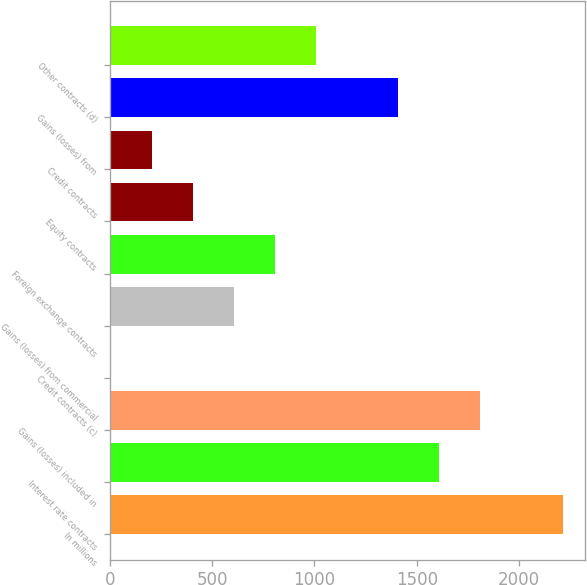Convert chart to OTSL. <chart><loc_0><loc_0><loc_500><loc_500><bar_chart><fcel>In millions<fcel>Interest rate contracts<fcel>Gains (losses) included in<fcel>Credit contracts (c)<fcel>Gains (losses) from commercial<fcel>Foreign exchange contracts<fcel>Equity contracts<fcel>Credit contracts<fcel>Gains (losses) from<fcel>Other contracts (d)<nl><fcel>2212.9<fcel>1610.2<fcel>1811.1<fcel>3<fcel>605.7<fcel>806.6<fcel>404.8<fcel>203.9<fcel>1409.3<fcel>1007.5<nl></chart> 